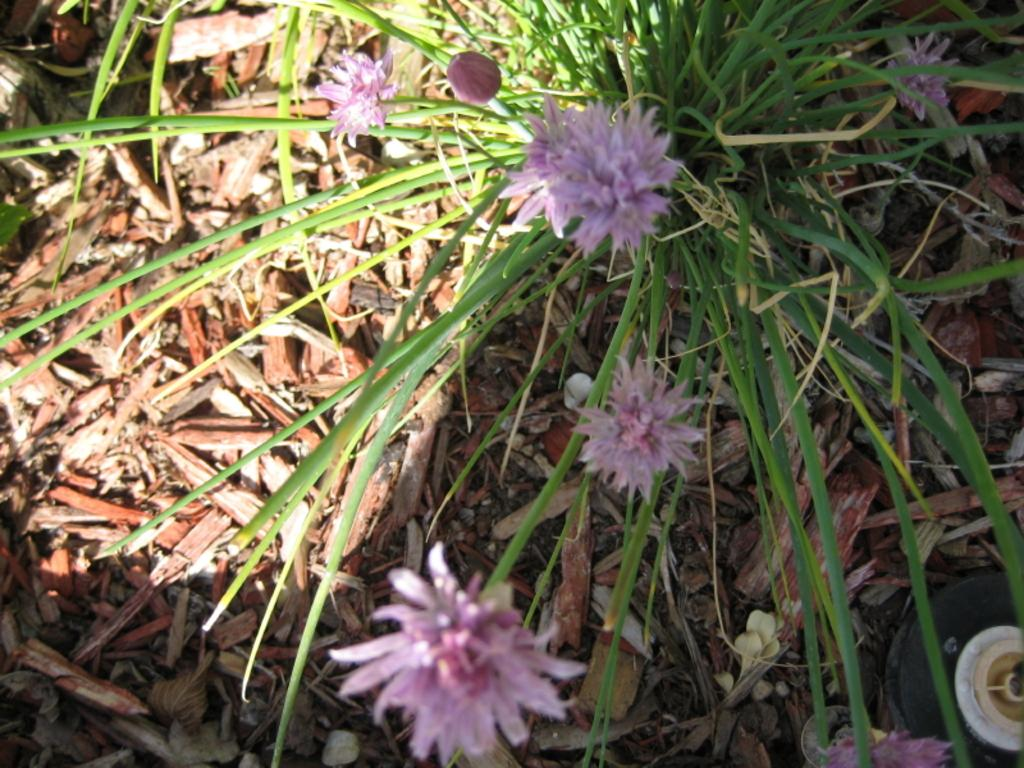What type of flora is present in the image? There are flowers in the image. What color are the flowers? The flowers are pink in color. What other plant-related object is visible in the image? There is a plant in the image. What color is the plant? The plant is green in color. What can be seen on the ground in the image? There are brown colored objects on the ground in the image. What month is depicted in the image? The image does not depict a month; it features flowers, a plant, and brown objects on the ground. What type of trousers are the flowers wearing in the image? The flowers are not wearing trousers, as they are inanimate objects and do not have clothing. 